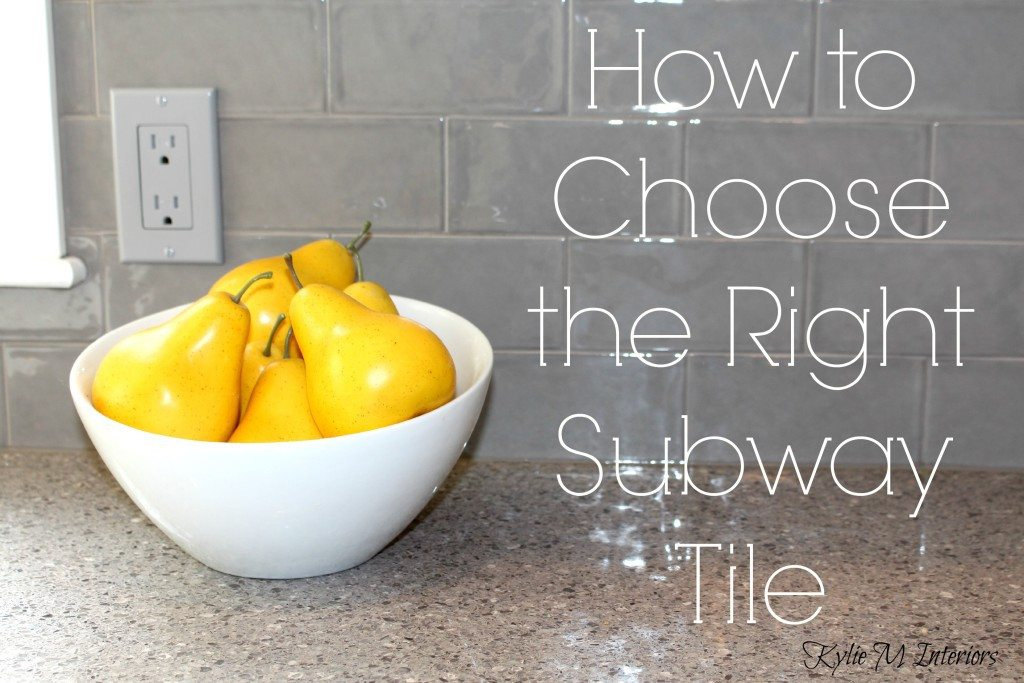Considering the design elements visible in the image, what might be the implications of choosing a subway tile of this particular color and finish for the lighting and perceived spaciousness of the kitchen? The selection of gray subway tiles with a glossy finish, as seen in the image, plays a significant role in shaping both the functional and aesthetic aspects of the kitchen. The reflective nature of the tiles' gloss can amplify natural and artificial light, casting a more vibrant glow across the room. This can make the kitchen not only brighter but also create an illusion of increased space, promoting a more open and inviting atmosphere. Additionally, the neutral hue of the tiles offers a versatile backdrop that harmonizes with various colors and textures present in the kitchen, from the stainless steel appliances to wooden cabinets, enhancing the room's overall coherence and timeless appeal. The use of such tiles can also ease future redesigns or updates, as their classic look integrates well with numerous décor styles, ensuring longevity in design satisfaction. 